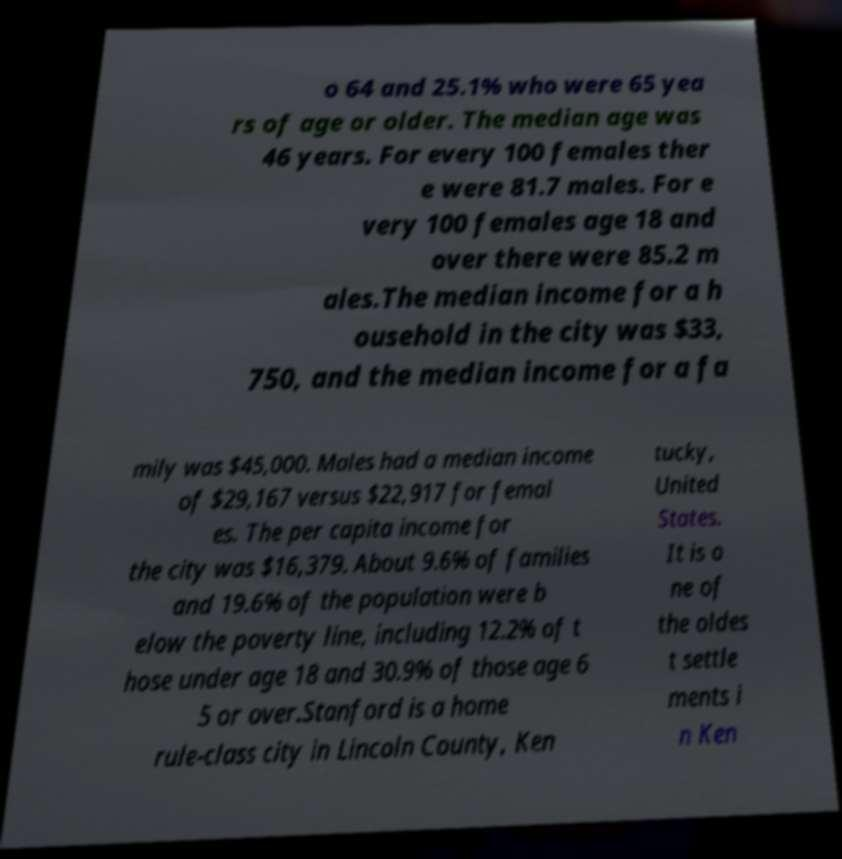Can you read and provide the text displayed in the image?This photo seems to have some interesting text. Can you extract and type it out for me? o 64 and 25.1% who were 65 yea rs of age or older. The median age was 46 years. For every 100 females ther e were 81.7 males. For e very 100 females age 18 and over there were 85.2 m ales.The median income for a h ousehold in the city was $33, 750, and the median income for a fa mily was $45,000. Males had a median income of $29,167 versus $22,917 for femal es. The per capita income for the city was $16,379. About 9.6% of families and 19.6% of the population were b elow the poverty line, including 12.2% of t hose under age 18 and 30.9% of those age 6 5 or over.Stanford is a home rule-class city in Lincoln County, Ken tucky, United States. It is o ne of the oldes t settle ments i n Ken 